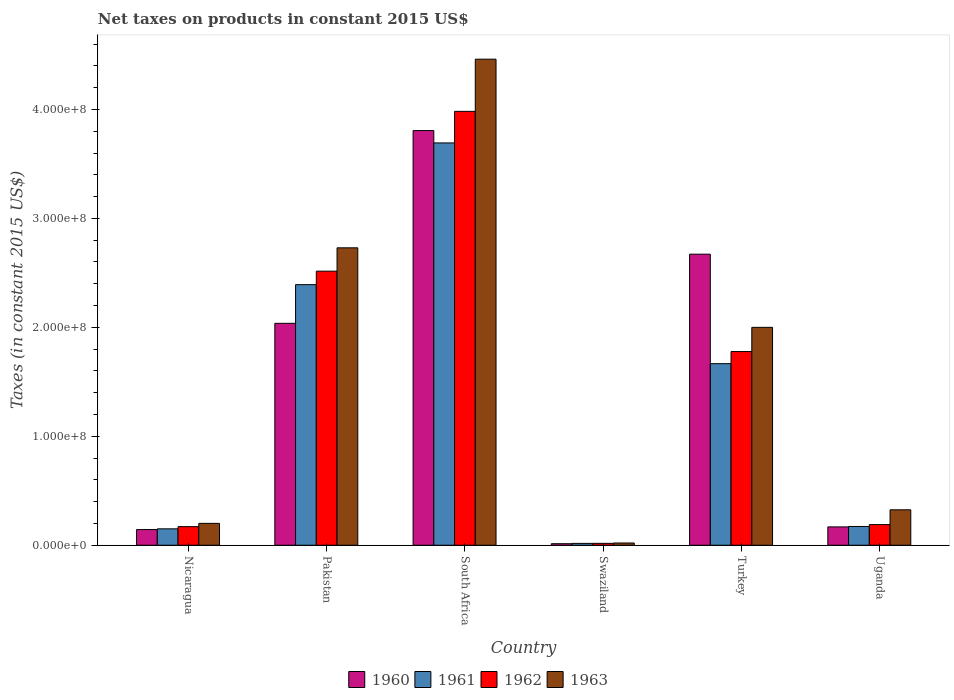Are the number of bars per tick equal to the number of legend labels?
Give a very brief answer. Yes. How many bars are there on the 3rd tick from the left?
Your answer should be compact. 4. How many bars are there on the 4th tick from the right?
Your response must be concise. 4. What is the label of the 6th group of bars from the left?
Give a very brief answer. Uganda. What is the net taxes on products in 1960 in Pakistan?
Your answer should be very brief. 2.04e+08. Across all countries, what is the maximum net taxes on products in 1963?
Provide a succinct answer. 4.46e+08. Across all countries, what is the minimum net taxes on products in 1963?
Offer a very short reply. 2.06e+06. In which country was the net taxes on products in 1962 maximum?
Make the answer very short. South Africa. In which country was the net taxes on products in 1961 minimum?
Ensure brevity in your answer.  Swaziland. What is the total net taxes on products in 1962 in the graph?
Your answer should be very brief. 8.65e+08. What is the difference between the net taxes on products in 1962 in Turkey and that in Uganda?
Your answer should be compact. 1.59e+08. What is the difference between the net taxes on products in 1962 in Turkey and the net taxes on products in 1961 in Uganda?
Ensure brevity in your answer.  1.61e+08. What is the average net taxes on products in 1963 per country?
Ensure brevity in your answer.  1.62e+08. What is the difference between the net taxes on products of/in 1960 and net taxes on products of/in 1962 in Nicaragua?
Offer a terse response. -2.68e+06. In how many countries, is the net taxes on products in 1961 greater than 100000000 US$?
Your answer should be very brief. 3. What is the ratio of the net taxes on products in 1960 in South Africa to that in Swaziland?
Provide a short and direct response. 271.17. Is the net taxes on products in 1963 in Turkey less than that in Uganda?
Provide a succinct answer. No. Is the difference between the net taxes on products in 1960 in Pakistan and Swaziland greater than the difference between the net taxes on products in 1962 in Pakistan and Swaziland?
Ensure brevity in your answer.  No. What is the difference between the highest and the second highest net taxes on products in 1960?
Make the answer very short. -6.35e+07. What is the difference between the highest and the lowest net taxes on products in 1960?
Ensure brevity in your answer.  3.79e+08. Is the sum of the net taxes on products in 1963 in South Africa and Uganda greater than the maximum net taxes on products in 1962 across all countries?
Give a very brief answer. Yes. Is it the case that in every country, the sum of the net taxes on products in 1960 and net taxes on products in 1962 is greater than the net taxes on products in 1963?
Make the answer very short. Yes. How many bars are there?
Provide a short and direct response. 24. Are all the bars in the graph horizontal?
Provide a succinct answer. No. How many countries are there in the graph?
Offer a terse response. 6. Does the graph contain any zero values?
Provide a succinct answer. No. What is the title of the graph?
Ensure brevity in your answer.  Net taxes on products in constant 2015 US$. Does "1967" appear as one of the legend labels in the graph?
Offer a very short reply. No. What is the label or title of the X-axis?
Your response must be concise. Country. What is the label or title of the Y-axis?
Ensure brevity in your answer.  Taxes (in constant 2015 US$). What is the Taxes (in constant 2015 US$) of 1960 in Nicaragua?
Ensure brevity in your answer.  1.44e+07. What is the Taxes (in constant 2015 US$) of 1961 in Nicaragua?
Provide a succinct answer. 1.51e+07. What is the Taxes (in constant 2015 US$) in 1962 in Nicaragua?
Keep it short and to the point. 1.71e+07. What is the Taxes (in constant 2015 US$) of 1963 in Nicaragua?
Your response must be concise. 2.01e+07. What is the Taxes (in constant 2015 US$) in 1960 in Pakistan?
Your answer should be compact. 2.04e+08. What is the Taxes (in constant 2015 US$) of 1961 in Pakistan?
Make the answer very short. 2.39e+08. What is the Taxes (in constant 2015 US$) in 1962 in Pakistan?
Offer a very short reply. 2.52e+08. What is the Taxes (in constant 2015 US$) of 1963 in Pakistan?
Your answer should be compact. 2.73e+08. What is the Taxes (in constant 2015 US$) in 1960 in South Africa?
Your answer should be compact. 3.81e+08. What is the Taxes (in constant 2015 US$) in 1961 in South Africa?
Offer a very short reply. 3.69e+08. What is the Taxes (in constant 2015 US$) of 1962 in South Africa?
Keep it short and to the point. 3.98e+08. What is the Taxes (in constant 2015 US$) in 1963 in South Africa?
Keep it short and to the point. 4.46e+08. What is the Taxes (in constant 2015 US$) of 1960 in Swaziland?
Offer a very short reply. 1.40e+06. What is the Taxes (in constant 2015 US$) in 1961 in Swaziland?
Your answer should be compact. 1.69e+06. What is the Taxes (in constant 2015 US$) in 1962 in Swaziland?
Your answer should be very brief. 1.73e+06. What is the Taxes (in constant 2015 US$) of 1963 in Swaziland?
Offer a very short reply. 2.06e+06. What is the Taxes (in constant 2015 US$) of 1960 in Turkey?
Your answer should be compact. 2.67e+08. What is the Taxes (in constant 2015 US$) in 1961 in Turkey?
Provide a succinct answer. 1.67e+08. What is the Taxes (in constant 2015 US$) of 1962 in Turkey?
Your response must be concise. 1.78e+08. What is the Taxes (in constant 2015 US$) in 1960 in Uganda?
Give a very brief answer. 1.68e+07. What is the Taxes (in constant 2015 US$) in 1961 in Uganda?
Provide a succinct answer. 1.72e+07. What is the Taxes (in constant 2015 US$) of 1962 in Uganda?
Give a very brief answer. 1.90e+07. What is the Taxes (in constant 2015 US$) of 1963 in Uganda?
Offer a terse response. 3.25e+07. Across all countries, what is the maximum Taxes (in constant 2015 US$) in 1960?
Your answer should be very brief. 3.81e+08. Across all countries, what is the maximum Taxes (in constant 2015 US$) in 1961?
Make the answer very short. 3.69e+08. Across all countries, what is the maximum Taxes (in constant 2015 US$) of 1962?
Your answer should be very brief. 3.98e+08. Across all countries, what is the maximum Taxes (in constant 2015 US$) of 1963?
Your response must be concise. 4.46e+08. Across all countries, what is the minimum Taxes (in constant 2015 US$) in 1960?
Provide a succinct answer. 1.40e+06. Across all countries, what is the minimum Taxes (in constant 2015 US$) in 1961?
Provide a succinct answer. 1.69e+06. Across all countries, what is the minimum Taxes (in constant 2015 US$) of 1962?
Your response must be concise. 1.73e+06. Across all countries, what is the minimum Taxes (in constant 2015 US$) of 1963?
Your response must be concise. 2.06e+06. What is the total Taxes (in constant 2015 US$) of 1960 in the graph?
Offer a terse response. 8.84e+08. What is the total Taxes (in constant 2015 US$) in 1961 in the graph?
Your answer should be compact. 8.09e+08. What is the total Taxes (in constant 2015 US$) in 1962 in the graph?
Your answer should be very brief. 8.65e+08. What is the total Taxes (in constant 2015 US$) of 1963 in the graph?
Offer a terse response. 9.74e+08. What is the difference between the Taxes (in constant 2015 US$) in 1960 in Nicaragua and that in Pakistan?
Make the answer very short. -1.89e+08. What is the difference between the Taxes (in constant 2015 US$) of 1961 in Nicaragua and that in Pakistan?
Your response must be concise. -2.24e+08. What is the difference between the Taxes (in constant 2015 US$) of 1962 in Nicaragua and that in Pakistan?
Offer a terse response. -2.35e+08. What is the difference between the Taxes (in constant 2015 US$) of 1963 in Nicaragua and that in Pakistan?
Offer a very short reply. -2.53e+08. What is the difference between the Taxes (in constant 2015 US$) in 1960 in Nicaragua and that in South Africa?
Your answer should be very brief. -3.66e+08. What is the difference between the Taxes (in constant 2015 US$) of 1961 in Nicaragua and that in South Africa?
Provide a succinct answer. -3.54e+08. What is the difference between the Taxes (in constant 2015 US$) of 1962 in Nicaragua and that in South Africa?
Provide a short and direct response. -3.81e+08. What is the difference between the Taxes (in constant 2015 US$) in 1963 in Nicaragua and that in South Africa?
Provide a succinct answer. -4.26e+08. What is the difference between the Taxes (in constant 2015 US$) of 1960 in Nicaragua and that in Swaziland?
Ensure brevity in your answer.  1.30e+07. What is the difference between the Taxes (in constant 2015 US$) in 1961 in Nicaragua and that in Swaziland?
Your answer should be compact. 1.34e+07. What is the difference between the Taxes (in constant 2015 US$) in 1962 in Nicaragua and that in Swaziland?
Give a very brief answer. 1.53e+07. What is the difference between the Taxes (in constant 2015 US$) in 1963 in Nicaragua and that in Swaziland?
Keep it short and to the point. 1.80e+07. What is the difference between the Taxes (in constant 2015 US$) of 1960 in Nicaragua and that in Turkey?
Give a very brief answer. -2.53e+08. What is the difference between the Taxes (in constant 2015 US$) of 1961 in Nicaragua and that in Turkey?
Your answer should be very brief. -1.52e+08. What is the difference between the Taxes (in constant 2015 US$) in 1962 in Nicaragua and that in Turkey?
Your answer should be very brief. -1.61e+08. What is the difference between the Taxes (in constant 2015 US$) of 1963 in Nicaragua and that in Turkey?
Provide a short and direct response. -1.80e+08. What is the difference between the Taxes (in constant 2015 US$) in 1960 in Nicaragua and that in Uganda?
Your response must be concise. -2.45e+06. What is the difference between the Taxes (in constant 2015 US$) in 1961 in Nicaragua and that in Uganda?
Keep it short and to the point. -2.17e+06. What is the difference between the Taxes (in constant 2015 US$) in 1962 in Nicaragua and that in Uganda?
Offer a very short reply. -1.89e+06. What is the difference between the Taxes (in constant 2015 US$) in 1963 in Nicaragua and that in Uganda?
Keep it short and to the point. -1.24e+07. What is the difference between the Taxes (in constant 2015 US$) in 1960 in Pakistan and that in South Africa?
Your answer should be compact. -1.77e+08. What is the difference between the Taxes (in constant 2015 US$) in 1961 in Pakistan and that in South Africa?
Provide a short and direct response. -1.30e+08. What is the difference between the Taxes (in constant 2015 US$) of 1962 in Pakistan and that in South Africa?
Ensure brevity in your answer.  -1.47e+08. What is the difference between the Taxes (in constant 2015 US$) in 1963 in Pakistan and that in South Africa?
Your response must be concise. -1.73e+08. What is the difference between the Taxes (in constant 2015 US$) of 1960 in Pakistan and that in Swaziland?
Provide a short and direct response. 2.02e+08. What is the difference between the Taxes (in constant 2015 US$) of 1961 in Pakistan and that in Swaziland?
Provide a succinct answer. 2.37e+08. What is the difference between the Taxes (in constant 2015 US$) of 1962 in Pakistan and that in Swaziland?
Your answer should be very brief. 2.50e+08. What is the difference between the Taxes (in constant 2015 US$) in 1963 in Pakistan and that in Swaziland?
Your response must be concise. 2.71e+08. What is the difference between the Taxes (in constant 2015 US$) of 1960 in Pakistan and that in Turkey?
Give a very brief answer. -6.35e+07. What is the difference between the Taxes (in constant 2015 US$) in 1961 in Pakistan and that in Turkey?
Your response must be concise. 7.25e+07. What is the difference between the Taxes (in constant 2015 US$) of 1962 in Pakistan and that in Turkey?
Give a very brief answer. 7.38e+07. What is the difference between the Taxes (in constant 2015 US$) of 1963 in Pakistan and that in Turkey?
Keep it short and to the point. 7.30e+07. What is the difference between the Taxes (in constant 2015 US$) of 1960 in Pakistan and that in Uganda?
Offer a very short reply. 1.87e+08. What is the difference between the Taxes (in constant 2015 US$) of 1961 in Pakistan and that in Uganda?
Your answer should be very brief. 2.22e+08. What is the difference between the Taxes (in constant 2015 US$) in 1962 in Pakistan and that in Uganda?
Make the answer very short. 2.33e+08. What is the difference between the Taxes (in constant 2015 US$) in 1963 in Pakistan and that in Uganda?
Provide a short and direct response. 2.40e+08. What is the difference between the Taxes (in constant 2015 US$) in 1960 in South Africa and that in Swaziland?
Offer a terse response. 3.79e+08. What is the difference between the Taxes (in constant 2015 US$) in 1961 in South Africa and that in Swaziland?
Offer a terse response. 3.68e+08. What is the difference between the Taxes (in constant 2015 US$) of 1962 in South Africa and that in Swaziland?
Give a very brief answer. 3.97e+08. What is the difference between the Taxes (in constant 2015 US$) in 1963 in South Africa and that in Swaziland?
Provide a succinct answer. 4.44e+08. What is the difference between the Taxes (in constant 2015 US$) of 1960 in South Africa and that in Turkey?
Give a very brief answer. 1.13e+08. What is the difference between the Taxes (in constant 2015 US$) of 1961 in South Africa and that in Turkey?
Your answer should be very brief. 2.03e+08. What is the difference between the Taxes (in constant 2015 US$) of 1962 in South Africa and that in Turkey?
Provide a succinct answer. 2.20e+08. What is the difference between the Taxes (in constant 2015 US$) of 1963 in South Africa and that in Turkey?
Make the answer very short. 2.46e+08. What is the difference between the Taxes (in constant 2015 US$) of 1960 in South Africa and that in Uganda?
Your answer should be very brief. 3.64e+08. What is the difference between the Taxes (in constant 2015 US$) in 1961 in South Africa and that in Uganda?
Your answer should be very brief. 3.52e+08. What is the difference between the Taxes (in constant 2015 US$) of 1962 in South Africa and that in Uganda?
Provide a short and direct response. 3.79e+08. What is the difference between the Taxes (in constant 2015 US$) of 1963 in South Africa and that in Uganda?
Offer a terse response. 4.14e+08. What is the difference between the Taxes (in constant 2015 US$) of 1960 in Swaziland and that in Turkey?
Your response must be concise. -2.66e+08. What is the difference between the Taxes (in constant 2015 US$) in 1961 in Swaziland and that in Turkey?
Keep it short and to the point. -1.65e+08. What is the difference between the Taxes (in constant 2015 US$) of 1962 in Swaziland and that in Turkey?
Your response must be concise. -1.76e+08. What is the difference between the Taxes (in constant 2015 US$) in 1963 in Swaziland and that in Turkey?
Provide a succinct answer. -1.98e+08. What is the difference between the Taxes (in constant 2015 US$) of 1960 in Swaziland and that in Uganda?
Your answer should be very brief. -1.54e+07. What is the difference between the Taxes (in constant 2015 US$) in 1961 in Swaziland and that in Uganda?
Keep it short and to the point. -1.55e+07. What is the difference between the Taxes (in constant 2015 US$) in 1962 in Swaziland and that in Uganda?
Make the answer very short. -1.72e+07. What is the difference between the Taxes (in constant 2015 US$) of 1963 in Swaziland and that in Uganda?
Provide a short and direct response. -3.05e+07. What is the difference between the Taxes (in constant 2015 US$) of 1960 in Turkey and that in Uganda?
Offer a terse response. 2.50e+08. What is the difference between the Taxes (in constant 2015 US$) of 1961 in Turkey and that in Uganda?
Your answer should be compact. 1.49e+08. What is the difference between the Taxes (in constant 2015 US$) in 1962 in Turkey and that in Uganda?
Your answer should be compact. 1.59e+08. What is the difference between the Taxes (in constant 2015 US$) in 1963 in Turkey and that in Uganda?
Ensure brevity in your answer.  1.67e+08. What is the difference between the Taxes (in constant 2015 US$) in 1960 in Nicaragua and the Taxes (in constant 2015 US$) in 1961 in Pakistan?
Ensure brevity in your answer.  -2.25e+08. What is the difference between the Taxes (in constant 2015 US$) of 1960 in Nicaragua and the Taxes (in constant 2015 US$) of 1962 in Pakistan?
Make the answer very short. -2.37e+08. What is the difference between the Taxes (in constant 2015 US$) in 1960 in Nicaragua and the Taxes (in constant 2015 US$) in 1963 in Pakistan?
Provide a short and direct response. -2.59e+08. What is the difference between the Taxes (in constant 2015 US$) in 1961 in Nicaragua and the Taxes (in constant 2015 US$) in 1962 in Pakistan?
Your response must be concise. -2.37e+08. What is the difference between the Taxes (in constant 2015 US$) of 1961 in Nicaragua and the Taxes (in constant 2015 US$) of 1963 in Pakistan?
Offer a very short reply. -2.58e+08. What is the difference between the Taxes (in constant 2015 US$) of 1962 in Nicaragua and the Taxes (in constant 2015 US$) of 1963 in Pakistan?
Your answer should be compact. -2.56e+08. What is the difference between the Taxes (in constant 2015 US$) of 1960 in Nicaragua and the Taxes (in constant 2015 US$) of 1961 in South Africa?
Give a very brief answer. -3.55e+08. What is the difference between the Taxes (in constant 2015 US$) of 1960 in Nicaragua and the Taxes (in constant 2015 US$) of 1962 in South Africa?
Offer a terse response. -3.84e+08. What is the difference between the Taxes (in constant 2015 US$) in 1960 in Nicaragua and the Taxes (in constant 2015 US$) in 1963 in South Africa?
Your answer should be compact. -4.32e+08. What is the difference between the Taxes (in constant 2015 US$) in 1961 in Nicaragua and the Taxes (in constant 2015 US$) in 1962 in South Africa?
Your response must be concise. -3.83e+08. What is the difference between the Taxes (in constant 2015 US$) in 1961 in Nicaragua and the Taxes (in constant 2015 US$) in 1963 in South Africa?
Ensure brevity in your answer.  -4.31e+08. What is the difference between the Taxes (in constant 2015 US$) in 1962 in Nicaragua and the Taxes (in constant 2015 US$) in 1963 in South Africa?
Your response must be concise. -4.29e+08. What is the difference between the Taxes (in constant 2015 US$) in 1960 in Nicaragua and the Taxes (in constant 2015 US$) in 1961 in Swaziland?
Provide a short and direct response. 1.27e+07. What is the difference between the Taxes (in constant 2015 US$) of 1960 in Nicaragua and the Taxes (in constant 2015 US$) of 1962 in Swaziland?
Offer a terse response. 1.27e+07. What is the difference between the Taxes (in constant 2015 US$) in 1960 in Nicaragua and the Taxes (in constant 2015 US$) in 1963 in Swaziland?
Offer a terse response. 1.23e+07. What is the difference between the Taxes (in constant 2015 US$) in 1961 in Nicaragua and the Taxes (in constant 2015 US$) in 1962 in Swaziland?
Ensure brevity in your answer.  1.33e+07. What is the difference between the Taxes (in constant 2015 US$) of 1961 in Nicaragua and the Taxes (in constant 2015 US$) of 1963 in Swaziland?
Your answer should be compact. 1.30e+07. What is the difference between the Taxes (in constant 2015 US$) of 1962 in Nicaragua and the Taxes (in constant 2015 US$) of 1963 in Swaziland?
Offer a very short reply. 1.50e+07. What is the difference between the Taxes (in constant 2015 US$) of 1960 in Nicaragua and the Taxes (in constant 2015 US$) of 1961 in Turkey?
Ensure brevity in your answer.  -1.52e+08. What is the difference between the Taxes (in constant 2015 US$) of 1960 in Nicaragua and the Taxes (in constant 2015 US$) of 1962 in Turkey?
Offer a very short reply. -1.63e+08. What is the difference between the Taxes (in constant 2015 US$) of 1960 in Nicaragua and the Taxes (in constant 2015 US$) of 1963 in Turkey?
Offer a terse response. -1.86e+08. What is the difference between the Taxes (in constant 2015 US$) of 1961 in Nicaragua and the Taxes (in constant 2015 US$) of 1962 in Turkey?
Make the answer very short. -1.63e+08. What is the difference between the Taxes (in constant 2015 US$) in 1961 in Nicaragua and the Taxes (in constant 2015 US$) in 1963 in Turkey?
Give a very brief answer. -1.85e+08. What is the difference between the Taxes (in constant 2015 US$) in 1962 in Nicaragua and the Taxes (in constant 2015 US$) in 1963 in Turkey?
Offer a very short reply. -1.83e+08. What is the difference between the Taxes (in constant 2015 US$) of 1960 in Nicaragua and the Taxes (in constant 2015 US$) of 1961 in Uganda?
Your answer should be very brief. -2.84e+06. What is the difference between the Taxes (in constant 2015 US$) of 1960 in Nicaragua and the Taxes (in constant 2015 US$) of 1962 in Uganda?
Keep it short and to the point. -4.57e+06. What is the difference between the Taxes (in constant 2015 US$) of 1960 in Nicaragua and the Taxes (in constant 2015 US$) of 1963 in Uganda?
Provide a short and direct response. -1.81e+07. What is the difference between the Taxes (in constant 2015 US$) in 1961 in Nicaragua and the Taxes (in constant 2015 US$) in 1962 in Uganda?
Provide a succinct answer. -3.90e+06. What is the difference between the Taxes (in constant 2015 US$) of 1961 in Nicaragua and the Taxes (in constant 2015 US$) of 1963 in Uganda?
Provide a short and direct response. -1.75e+07. What is the difference between the Taxes (in constant 2015 US$) of 1962 in Nicaragua and the Taxes (in constant 2015 US$) of 1963 in Uganda?
Your response must be concise. -1.55e+07. What is the difference between the Taxes (in constant 2015 US$) of 1960 in Pakistan and the Taxes (in constant 2015 US$) of 1961 in South Africa?
Your answer should be very brief. -1.66e+08. What is the difference between the Taxes (in constant 2015 US$) of 1960 in Pakistan and the Taxes (in constant 2015 US$) of 1962 in South Africa?
Ensure brevity in your answer.  -1.95e+08. What is the difference between the Taxes (in constant 2015 US$) in 1960 in Pakistan and the Taxes (in constant 2015 US$) in 1963 in South Africa?
Offer a terse response. -2.42e+08. What is the difference between the Taxes (in constant 2015 US$) of 1961 in Pakistan and the Taxes (in constant 2015 US$) of 1962 in South Africa?
Your response must be concise. -1.59e+08. What is the difference between the Taxes (in constant 2015 US$) in 1961 in Pakistan and the Taxes (in constant 2015 US$) in 1963 in South Africa?
Provide a succinct answer. -2.07e+08. What is the difference between the Taxes (in constant 2015 US$) in 1962 in Pakistan and the Taxes (in constant 2015 US$) in 1963 in South Africa?
Offer a terse response. -1.95e+08. What is the difference between the Taxes (in constant 2015 US$) of 1960 in Pakistan and the Taxes (in constant 2015 US$) of 1961 in Swaziland?
Provide a succinct answer. 2.02e+08. What is the difference between the Taxes (in constant 2015 US$) of 1960 in Pakistan and the Taxes (in constant 2015 US$) of 1962 in Swaziland?
Keep it short and to the point. 2.02e+08. What is the difference between the Taxes (in constant 2015 US$) in 1960 in Pakistan and the Taxes (in constant 2015 US$) in 1963 in Swaziland?
Make the answer very short. 2.02e+08. What is the difference between the Taxes (in constant 2015 US$) of 1961 in Pakistan and the Taxes (in constant 2015 US$) of 1962 in Swaziland?
Your response must be concise. 2.37e+08. What is the difference between the Taxes (in constant 2015 US$) in 1961 in Pakistan and the Taxes (in constant 2015 US$) in 1963 in Swaziland?
Provide a short and direct response. 2.37e+08. What is the difference between the Taxes (in constant 2015 US$) of 1962 in Pakistan and the Taxes (in constant 2015 US$) of 1963 in Swaziland?
Your response must be concise. 2.50e+08. What is the difference between the Taxes (in constant 2015 US$) in 1960 in Pakistan and the Taxes (in constant 2015 US$) in 1961 in Turkey?
Ensure brevity in your answer.  3.70e+07. What is the difference between the Taxes (in constant 2015 US$) of 1960 in Pakistan and the Taxes (in constant 2015 US$) of 1962 in Turkey?
Your response must be concise. 2.59e+07. What is the difference between the Taxes (in constant 2015 US$) of 1960 in Pakistan and the Taxes (in constant 2015 US$) of 1963 in Turkey?
Your answer should be compact. 3.70e+06. What is the difference between the Taxes (in constant 2015 US$) of 1961 in Pakistan and the Taxes (in constant 2015 US$) of 1962 in Turkey?
Give a very brief answer. 6.14e+07. What is the difference between the Taxes (in constant 2015 US$) in 1961 in Pakistan and the Taxes (in constant 2015 US$) in 1963 in Turkey?
Provide a succinct answer. 3.92e+07. What is the difference between the Taxes (in constant 2015 US$) of 1962 in Pakistan and the Taxes (in constant 2015 US$) of 1963 in Turkey?
Your answer should be compact. 5.16e+07. What is the difference between the Taxes (in constant 2015 US$) of 1960 in Pakistan and the Taxes (in constant 2015 US$) of 1961 in Uganda?
Give a very brief answer. 1.86e+08. What is the difference between the Taxes (in constant 2015 US$) in 1960 in Pakistan and the Taxes (in constant 2015 US$) in 1962 in Uganda?
Keep it short and to the point. 1.85e+08. What is the difference between the Taxes (in constant 2015 US$) in 1960 in Pakistan and the Taxes (in constant 2015 US$) in 1963 in Uganda?
Your answer should be compact. 1.71e+08. What is the difference between the Taxes (in constant 2015 US$) in 1961 in Pakistan and the Taxes (in constant 2015 US$) in 1962 in Uganda?
Your answer should be very brief. 2.20e+08. What is the difference between the Taxes (in constant 2015 US$) in 1961 in Pakistan and the Taxes (in constant 2015 US$) in 1963 in Uganda?
Ensure brevity in your answer.  2.07e+08. What is the difference between the Taxes (in constant 2015 US$) in 1962 in Pakistan and the Taxes (in constant 2015 US$) in 1963 in Uganda?
Give a very brief answer. 2.19e+08. What is the difference between the Taxes (in constant 2015 US$) in 1960 in South Africa and the Taxes (in constant 2015 US$) in 1961 in Swaziland?
Ensure brevity in your answer.  3.79e+08. What is the difference between the Taxes (in constant 2015 US$) of 1960 in South Africa and the Taxes (in constant 2015 US$) of 1962 in Swaziland?
Provide a succinct answer. 3.79e+08. What is the difference between the Taxes (in constant 2015 US$) in 1960 in South Africa and the Taxes (in constant 2015 US$) in 1963 in Swaziland?
Keep it short and to the point. 3.79e+08. What is the difference between the Taxes (in constant 2015 US$) of 1961 in South Africa and the Taxes (in constant 2015 US$) of 1962 in Swaziland?
Provide a succinct answer. 3.68e+08. What is the difference between the Taxes (in constant 2015 US$) in 1961 in South Africa and the Taxes (in constant 2015 US$) in 1963 in Swaziland?
Provide a short and direct response. 3.67e+08. What is the difference between the Taxes (in constant 2015 US$) of 1962 in South Africa and the Taxes (in constant 2015 US$) of 1963 in Swaziland?
Your response must be concise. 3.96e+08. What is the difference between the Taxes (in constant 2015 US$) of 1960 in South Africa and the Taxes (in constant 2015 US$) of 1961 in Turkey?
Offer a terse response. 2.14e+08. What is the difference between the Taxes (in constant 2015 US$) of 1960 in South Africa and the Taxes (in constant 2015 US$) of 1962 in Turkey?
Keep it short and to the point. 2.03e+08. What is the difference between the Taxes (in constant 2015 US$) in 1960 in South Africa and the Taxes (in constant 2015 US$) in 1963 in Turkey?
Offer a very short reply. 1.81e+08. What is the difference between the Taxes (in constant 2015 US$) in 1961 in South Africa and the Taxes (in constant 2015 US$) in 1962 in Turkey?
Provide a succinct answer. 1.91e+08. What is the difference between the Taxes (in constant 2015 US$) of 1961 in South Africa and the Taxes (in constant 2015 US$) of 1963 in Turkey?
Provide a short and direct response. 1.69e+08. What is the difference between the Taxes (in constant 2015 US$) of 1962 in South Africa and the Taxes (in constant 2015 US$) of 1963 in Turkey?
Provide a succinct answer. 1.98e+08. What is the difference between the Taxes (in constant 2015 US$) of 1960 in South Africa and the Taxes (in constant 2015 US$) of 1961 in Uganda?
Keep it short and to the point. 3.63e+08. What is the difference between the Taxes (in constant 2015 US$) in 1960 in South Africa and the Taxes (in constant 2015 US$) in 1962 in Uganda?
Your answer should be compact. 3.62e+08. What is the difference between the Taxes (in constant 2015 US$) in 1960 in South Africa and the Taxes (in constant 2015 US$) in 1963 in Uganda?
Keep it short and to the point. 3.48e+08. What is the difference between the Taxes (in constant 2015 US$) in 1961 in South Africa and the Taxes (in constant 2015 US$) in 1962 in Uganda?
Ensure brevity in your answer.  3.50e+08. What is the difference between the Taxes (in constant 2015 US$) of 1961 in South Africa and the Taxes (in constant 2015 US$) of 1963 in Uganda?
Provide a succinct answer. 3.37e+08. What is the difference between the Taxes (in constant 2015 US$) of 1962 in South Africa and the Taxes (in constant 2015 US$) of 1963 in Uganda?
Make the answer very short. 3.66e+08. What is the difference between the Taxes (in constant 2015 US$) in 1960 in Swaziland and the Taxes (in constant 2015 US$) in 1961 in Turkey?
Make the answer very short. -1.65e+08. What is the difference between the Taxes (in constant 2015 US$) in 1960 in Swaziland and the Taxes (in constant 2015 US$) in 1962 in Turkey?
Make the answer very short. -1.76e+08. What is the difference between the Taxes (in constant 2015 US$) in 1960 in Swaziland and the Taxes (in constant 2015 US$) in 1963 in Turkey?
Provide a succinct answer. -1.99e+08. What is the difference between the Taxes (in constant 2015 US$) in 1961 in Swaziland and the Taxes (in constant 2015 US$) in 1962 in Turkey?
Ensure brevity in your answer.  -1.76e+08. What is the difference between the Taxes (in constant 2015 US$) of 1961 in Swaziland and the Taxes (in constant 2015 US$) of 1963 in Turkey?
Keep it short and to the point. -1.98e+08. What is the difference between the Taxes (in constant 2015 US$) in 1962 in Swaziland and the Taxes (in constant 2015 US$) in 1963 in Turkey?
Provide a succinct answer. -1.98e+08. What is the difference between the Taxes (in constant 2015 US$) in 1960 in Swaziland and the Taxes (in constant 2015 US$) in 1961 in Uganda?
Provide a short and direct response. -1.58e+07. What is the difference between the Taxes (in constant 2015 US$) in 1960 in Swaziland and the Taxes (in constant 2015 US$) in 1962 in Uganda?
Your answer should be compact. -1.76e+07. What is the difference between the Taxes (in constant 2015 US$) of 1960 in Swaziland and the Taxes (in constant 2015 US$) of 1963 in Uganda?
Make the answer very short. -3.11e+07. What is the difference between the Taxes (in constant 2015 US$) of 1961 in Swaziland and the Taxes (in constant 2015 US$) of 1962 in Uganda?
Offer a very short reply. -1.73e+07. What is the difference between the Taxes (in constant 2015 US$) of 1961 in Swaziland and the Taxes (in constant 2015 US$) of 1963 in Uganda?
Your answer should be very brief. -3.08e+07. What is the difference between the Taxes (in constant 2015 US$) of 1962 in Swaziland and the Taxes (in constant 2015 US$) of 1963 in Uganda?
Offer a very short reply. -3.08e+07. What is the difference between the Taxes (in constant 2015 US$) in 1960 in Turkey and the Taxes (in constant 2015 US$) in 1961 in Uganda?
Offer a terse response. 2.50e+08. What is the difference between the Taxes (in constant 2015 US$) in 1960 in Turkey and the Taxes (in constant 2015 US$) in 1962 in Uganda?
Give a very brief answer. 2.48e+08. What is the difference between the Taxes (in constant 2015 US$) of 1960 in Turkey and the Taxes (in constant 2015 US$) of 1963 in Uganda?
Keep it short and to the point. 2.35e+08. What is the difference between the Taxes (in constant 2015 US$) in 1961 in Turkey and the Taxes (in constant 2015 US$) in 1962 in Uganda?
Your response must be concise. 1.48e+08. What is the difference between the Taxes (in constant 2015 US$) in 1961 in Turkey and the Taxes (in constant 2015 US$) in 1963 in Uganda?
Provide a succinct answer. 1.34e+08. What is the difference between the Taxes (in constant 2015 US$) of 1962 in Turkey and the Taxes (in constant 2015 US$) of 1963 in Uganda?
Your answer should be very brief. 1.45e+08. What is the average Taxes (in constant 2015 US$) in 1960 per country?
Keep it short and to the point. 1.47e+08. What is the average Taxes (in constant 2015 US$) of 1961 per country?
Keep it short and to the point. 1.35e+08. What is the average Taxes (in constant 2015 US$) of 1962 per country?
Provide a succinct answer. 1.44e+08. What is the average Taxes (in constant 2015 US$) of 1963 per country?
Offer a very short reply. 1.62e+08. What is the difference between the Taxes (in constant 2015 US$) of 1960 and Taxes (in constant 2015 US$) of 1961 in Nicaragua?
Your response must be concise. -6.69e+05. What is the difference between the Taxes (in constant 2015 US$) of 1960 and Taxes (in constant 2015 US$) of 1962 in Nicaragua?
Provide a short and direct response. -2.68e+06. What is the difference between the Taxes (in constant 2015 US$) of 1960 and Taxes (in constant 2015 US$) of 1963 in Nicaragua?
Provide a succinct answer. -5.69e+06. What is the difference between the Taxes (in constant 2015 US$) in 1961 and Taxes (in constant 2015 US$) in 1962 in Nicaragua?
Your response must be concise. -2.01e+06. What is the difference between the Taxes (in constant 2015 US$) of 1961 and Taxes (in constant 2015 US$) of 1963 in Nicaragua?
Keep it short and to the point. -5.02e+06. What is the difference between the Taxes (in constant 2015 US$) in 1962 and Taxes (in constant 2015 US$) in 1963 in Nicaragua?
Offer a terse response. -3.01e+06. What is the difference between the Taxes (in constant 2015 US$) in 1960 and Taxes (in constant 2015 US$) in 1961 in Pakistan?
Your response must be concise. -3.55e+07. What is the difference between the Taxes (in constant 2015 US$) of 1960 and Taxes (in constant 2015 US$) of 1962 in Pakistan?
Give a very brief answer. -4.79e+07. What is the difference between the Taxes (in constant 2015 US$) in 1960 and Taxes (in constant 2015 US$) in 1963 in Pakistan?
Your answer should be compact. -6.93e+07. What is the difference between the Taxes (in constant 2015 US$) of 1961 and Taxes (in constant 2015 US$) of 1962 in Pakistan?
Make the answer very short. -1.24e+07. What is the difference between the Taxes (in constant 2015 US$) in 1961 and Taxes (in constant 2015 US$) in 1963 in Pakistan?
Your response must be concise. -3.38e+07. What is the difference between the Taxes (in constant 2015 US$) in 1962 and Taxes (in constant 2015 US$) in 1963 in Pakistan?
Your answer should be very brief. -2.14e+07. What is the difference between the Taxes (in constant 2015 US$) in 1960 and Taxes (in constant 2015 US$) in 1961 in South Africa?
Your answer should be compact. 1.13e+07. What is the difference between the Taxes (in constant 2015 US$) of 1960 and Taxes (in constant 2015 US$) of 1962 in South Africa?
Make the answer very short. -1.76e+07. What is the difference between the Taxes (in constant 2015 US$) in 1960 and Taxes (in constant 2015 US$) in 1963 in South Africa?
Ensure brevity in your answer.  -6.55e+07. What is the difference between the Taxes (in constant 2015 US$) in 1961 and Taxes (in constant 2015 US$) in 1962 in South Africa?
Your response must be concise. -2.90e+07. What is the difference between the Taxes (in constant 2015 US$) in 1961 and Taxes (in constant 2015 US$) in 1963 in South Africa?
Your response must be concise. -7.69e+07. What is the difference between the Taxes (in constant 2015 US$) of 1962 and Taxes (in constant 2015 US$) of 1963 in South Africa?
Keep it short and to the point. -4.79e+07. What is the difference between the Taxes (in constant 2015 US$) of 1960 and Taxes (in constant 2015 US$) of 1961 in Swaziland?
Make the answer very short. -2.89e+05. What is the difference between the Taxes (in constant 2015 US$) in 1960 and Taxes (in constant 2015 US$) in 1962 in Swaziland?
Your answer should be very brief. -3.30e+05. What is the difference between the Taxes (in constant 2015 US$) of 1960 and Taxes (in constant 2015 US$) of 1963 in Swaziland?
Your response must be concise. -6.61e+05. What is the difference between the Taxes (in constant 2015 US$) in 1961 and Taxes (in constant 2015 US$) in 1962 in Swaziland?
Your answer should be very brief. -4.13e+04. What is the difference between the Taxes (in constant 2015 US$) in 1961 and Taxes (in constant 2015 US$) in 1963 in Swaziland?
Ensure brevity in your answer.  -3.72e+05. What is the difference between the Taxes (in constant 2015 US$) of 1962 and Taxes (in constant 2015 US$) of 1963 in Swaziland?
Offer a very short reply. -3.30e+05. What is the difference between the Taxes (in constant 2015 US$) in 1960 and Taxes (in constant 2015 US$) in 1961 in Turkey?
Your answer should be compact. 1.00e+08. What is the difference between the Taxes (in constant 2015 US$) in 1960 and Taxes (in constant 2015 US$) in 1962 in Turkey?
Make the answer very short. 8.94e+07. What is the difference between the Taxes (in constant 2015 US$) in 1960 and Taxes (in constant 2015 US$) in 1963 in Turkey?
Your response must be concise. 6.72e+07. What is the difference between the Taxes (in constant 2015 US$) of 1961 and Taxes (in constant 2015 US$) of 1962 in Turkey?
Ensure brevity in your answer.  -1.11e+07. What is the difference between the Taxes (in constant 2015 US$) of 1961 and Taxes (in constant 2015 US$) of 1963 in Turkey?
Your answer should be very brief. -3.33e+07. What is the difference between the Taxes (in constant 2015 US$) of 1962 and Taxes (in constant 2015 US$) of 1963 in Turkey?
Make the answer very short. -2.22e+07. What is the difference between the Taxes (in constant 2015 US$) of 1960 and Taxes (in constant 2015 US$) of 1961 in Uganda?
Ensure brevity in your answer.  -3.85e+05. What is the difference between the Taxes (in constant 2015 US$) in 1960 and Taxes (in constant 2015 US$) in 1962 in Uganda?
Provide a succinct answer. -2.12e+06. What is the difference between the Taxes (in constant 2015 US$) in 1960 and Taxes (in constant 2015 US$) in 1963 in Uganda?
Provide a succinct answer. -1.57e+07. What is the difference between the Taxes (in constant 2015 US$) in 1961 and Taxes (in constant 2015 US$) in 1962 in Uganda?
Offer a terse response. -1.73e+06. What is the difference between the Taxes (in constant 2015 US$) of 1961 and Taxes (in constant 2015 US$) of 1963 in Uganda?
Offer a very short reply. -1.53e+07. What is the difference between the Taxes (in constant 2015 US$) in 1962 and Taxes (in constant 2015 US$) in 1963 in Uganda?
Provide a short and direct response. -1.36e+07. What is the ratio of the Taxes (in constant 2015 US$) in 1960 in Nicaragua to that in Pakistan?
Give a very brief answer. 0.07. What is the ratio of the Taxes (in constant 2015 US$) in 1961 in Nicaragua to that in Pakistan?
Offer a terse response. 0.06. What is the ratio of the Taxes (in constant 2015 US$) in 1962 in Nicaragua to that in Pakistan?
Provide a succinct answer. 0.07. What is the ratio of the Taxes (in constant 2015 US$) of 1963 in Nicaragua to that in Pakistan?
Offer a terse response. 0.07. What is the ratio of the Taxes (in constant 2015 US$) in 1960 in Nicaragua to that in South Africa?
Keep it short and to the point. 0.04. What is the ratio of the Taxes (in constant 2015 US$) in 1961 in Nicaragua to that in South Africa?
Provide a succinct answer. 0.04. What is the ratio of the Taxes (in constant 2015 US$) of 1962 in Nicaragua to that in South Africa?
Ensure brevity in your answer.  0.04. What is the ratio of the Taxes (in constant 2015 US$) in 1963 in Nicaragua to that in South Africa?
Provide a succinct answer. 0.04. What is the ratio of the Taxes (in constant 2015 US$) in 1960 in Nicaragua to that in Swaziland?
Ensure brevity in your answer.  10.25. What is the ratio of the Taxes (in constant 2015 US$) in 1961 in Nicaragua to that in Swaziland?
Provide a short and direct response. 8.89. What is the ratio of the Taxes (in constant 2015 US$) of 1962 in Nicaragua to that in Swaziland?
Your answer should be compact. 9.84. What is the ratio of the Taxes (in constant 2015 US$) in 1963 in Nicaragua to that in Swaziland?
Offer a terse response. 9.73. What is the ratio of the Taxes (in constant 2015 US$) of 1960 in Nicaragua to that in Turkey?
Give a very brief answer. 0.05. What is the ratio of the Taxes (in constant 2015 US$) in 1961 in Nicaragua to that in Turkey?
Keep it short and to the point. 0.09. What is the ratio of the Taxes (in constant 2015 US$) in 1962 in Nicaragua to that in Turkey?
Ensure brevity in your answer.  0.1. What is the ratio of the Taxes (in constant 2015 US$) in 1963 in Nicaragua to that in Turkey?
Give a very brief answer. 0.1. What is the ratio of the Taxes (in constant 2015 US$) in 1960 in Nicaragua to that in Uganda?
Ensure brevity in your answer.  0.85. What is the ratio of the Taxes (in constant 2015 US$) of 1961 in Nicaragua to that in Uganda?
Make the answer very short. 0.87. What is the ratio of the Taxes (in constant 2015 US$) in 1962 in Nicaragua to that in Uganda?
Your answer should be compact. 0.9. What is the ratio of the Taxes (in constant 2015 US$) in 1963 in Nicaragua to that in Uganda?
Your response must be concise. 0.62. What is the ratio of the Taxes (in constant 2015 US$) in 1960 in Pakistan to that in South Africa?
Give a very brief answer. 0.54. What is the ratio of the Taxes (in constant 2015 US$) of 1961 in Pakistan to that in South Africa?
Your answer should be compact. 0.65. What is the ratio of the Taxes (in constant 2015 US$) of 1962 in Pakistan to that in South Africa?
Make the answer very short. 0.63. What is the ratio of the Taxes (in constant 2015 US$) of 1963 in Pakistan to that in South Africa?
Your answer should be very brief. 0.61. What is the ratio of the Taxes (in constant 2015 US$) in 1960 in Pakistan to that in Swaziland?
Provide a succinct answer. 145.12. What is the ratio of the Taxes (in constant 2015 US$) in 1961 in Pakistan to that in Swaziland?
Give a very brief answer. 141.31. What is the ratio of the Taxes (in constant 2015 US$) in 1962 in Pakistan to that in Swaziland?
Your answer should be very brief. 145.09. What is the ratio of the Taxes (in constant 2015 US$) in 1963 in Pakistan to that in Swaziland?
Offer a terse response. 132.25. What is the ratio of the Taxes (in constant 2015 US$) in 1960 in Pakistan to that in Turkey?
Your response must be concise. 0.76. What is the ratio of the Taxes (in constant 2015 US$) of 1961 in Pakistan to that in Turkey?
Make the answer very short. 1.44. What is the ratio of the Taxes (in constant 2015 US$) of 1962 in Pakistan to that in Turkey?
Your answer should be compact. 1.42. What is the ratio of the Taxes (in constant 2015 US$) in 1963 in Pakistan to that in Turkey?
Your answer should be compact. 1.36. What is the ratio of the Taxes (in constant 2015 US$) of 1960 in Pakistan to that in Uganda?
Keep it short and to the point. 12.1. What is the ratio of the Taxes (in constant 2015 US$) of 1961 in Pakistan to that in Uganda?
Provide a short and direct response. 13.89. What is the ratio of the Taxes (in constant 2015 US$) in 1962 in Pakistan to that in Uganda?
Ensure brevity in your answer.  13.27. What is the ratio of the Taxes (in constant 2015 US$) in 1963 in Pakistan to that in Uganda?
Your answer should be very brief. 8.39. What is the ratio of the Taxes (in constant 2015 US$) in 1960 in South Africa to that in Swaziland?
Provide a short and direct response. 271.17. What is the ratio of the Taxes (in constant 2015 US$) in 1961 in South Africa to that in Swaziland?
Provide a short and direct response. 218.17. What is the ratio of the Taxes (in constant 2015 US$) of 1962 in South Africa to that in Swaziland?
Keep it short and to the point. 229.69. What is the ratio of the Taxes (in constant 2015 US$) of 1963 in South Africa to that in Swaziland?
Provide a succinct answer. 216.15. What is the ratio of the Taxes (in constant 2015 US$) in 1960 in South Africa to that in Turkey?
Your response must be concise. 1.42. What is the ratio of the Taxes (in constant 2015 US$) of 1961 in South Africa to that in Turkey?
Your answer should be compact. 2.22. What is the ratio of the Taxes (in constant 2015 US$) in 1962 in South Africa to that in Turkey?
Keep it short and to the point. 2.24. What is the ratio of the Taxes (in constant 2015 US$) of 1963 in South Africa to that in Turkey?
Your answer should be very brief. 2.23. What is the ratio of the Taxes (in constant 2015 US$) in 1960 in South Africa to that in Uganda?
Provide a succinct answer. 22.6. What is the ratio of the Taxes (in constant 2015 US$) in 1961 in South Africa to that in Uganda?
Your response must be concise. 21.44. What is the ratio of the Taxes (in constant 2015 US$) of 1962 in South Africa to that in Uganda?
Ensure brevity in your answer.  21.01. What is the ratio of the Taxes (in constant 2015 US$) in 1963 in South Africa to that in Uganda?
Your answer should be compact. 13.72. What is the ratio of the Taxes (in constant 2015 US$) in 1960 in Swaziland to that in Turkey?
Your response must be concise. 0.01. What is the ratio of the Taxes (in constant 2015 US$) of 1961 in Swaziland to that in Turkey?
Offer a terse response. 0.01. What is the ratio of the Taxes (in constant 2015 US$) of 1962 in Swaziland to that in Turkey?
Ensure brevity in your answer.  0.01. What is the ratio of the Taxes (in constant 2015 US$) of 1963 in Swaziland to that in Turkey?
Give a very brief answer. 0.01. What is the ratio of the Taxes (in constant 2015 US$) of 1960 in Swaziland to that in Uganda?
Keep it short and to the point. 0.08. What is the ratio of the Taxes (in constant 2015 US$) of 1961 in Swaziland to that in Uganda?
Your response must be concise. 0.1. What is the ratio of the Taxes (in constant 2015 US$) in 1962 in Swaziland to that in Uganda?
Keep it short and to the point. 0.09. What is the ratio of the Taxes (in constant 2015 US$) in 1963 in Swaziland to that in Uganda?
Provide a succinct answer. 0.06. What is the ratio of the Taxes (in constant 2015 US$) in 1960 in Turkey to that in Uganda?
Your answer should be very brief. 15.86. What is the ratio of the Taxes (in constant 2015 US$) of 1961 in Turkey to that in Uganda?
Your answer should be very brief. 9.68. What is the ratio of the Taxes (in constant 2015 US$) in 1962 in Turkey to that in Uganda?
Keep it short and to the point. 9.38. What is the ratio of the Taxes (in constant 2015 US$) in 1963 in Turkey to that in Uganda?
Keep it short and to the point. 6.15. What is the difference between the highest and the second highest Taxes (in constant 2015 US$) of 1960?
Provide a short and direct response. 1.13e+08. What is the difference between the highest and the second highest Taxes (in constant 2015 US$) of 1961?
Give a very brief answer. 1.30e+08. What is the difference between the highest and the second highest Taxes (in constant 2015 US$) of 1962?
Ensure brevity in your answer.  1.47e+08. What is the difference between the highest and the second highest Taxes (in constant 2015 US$) in 1963?
Make the answer very short. 1.73e+08. What is the difference between the highest and the lowest Taxes (in constant 2015 US$) in 1960?
Make the answer very short. 3.79e+08. What is the difference between the highest and the lowest Taxes (in constant 2015 US$) in 1961?
Your response must be concise. 3.68e+08. What is the difference between the highest and the lowest Taxes (in constant 2015 US$) of 1962?
Your answer should be very brief. 3.97e+08. What is the difference between the highest and the lowest Taxes (in constant 2015 US$) in 1963?
Provide a succinct answer. 4.44e+08. 